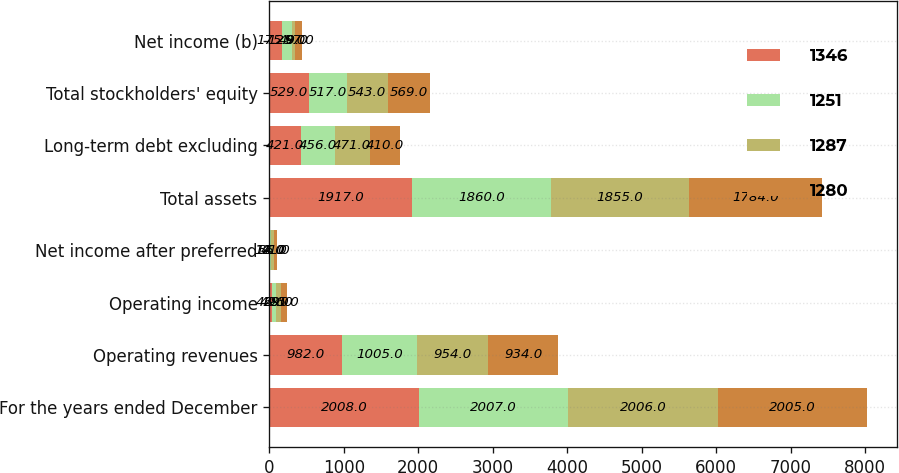Convert chart. <chart><loc_0><loc_0><loc_500><loc_500><stacked_bar_chart><ecel><fcel>For the years ended December<fcel>Operating revenues<fcel>Operating income<fcel>Net income after preferred<fcel>Total assets<fcel>Long-term debt excluding<fcel>Total stockholders' equity<fcel>Net income (b)<nl><fcel>1346<fcel>2008<fcel>982<fcel>42<fcel>12<fcel>1917<fcel>421<fcel>529<fcel>175<nl><fcel>1251<fcel>2007<fcel>1005<fcel>49<fcel>14<fcel>1860<fcel>456<fcel>517<fcel>125<nl><fcel>1287<fcel>2006<fcel>954<fcel>69<fcel>35<fcel>1855<fcel>471<fcel>543<fcel>49<nl><fcel>1280<fcel>2005<fcel>934<fcel>85<fcel>41<fcel>1784<fcel>410<fcel>569<fcel>97<nl></chart> 